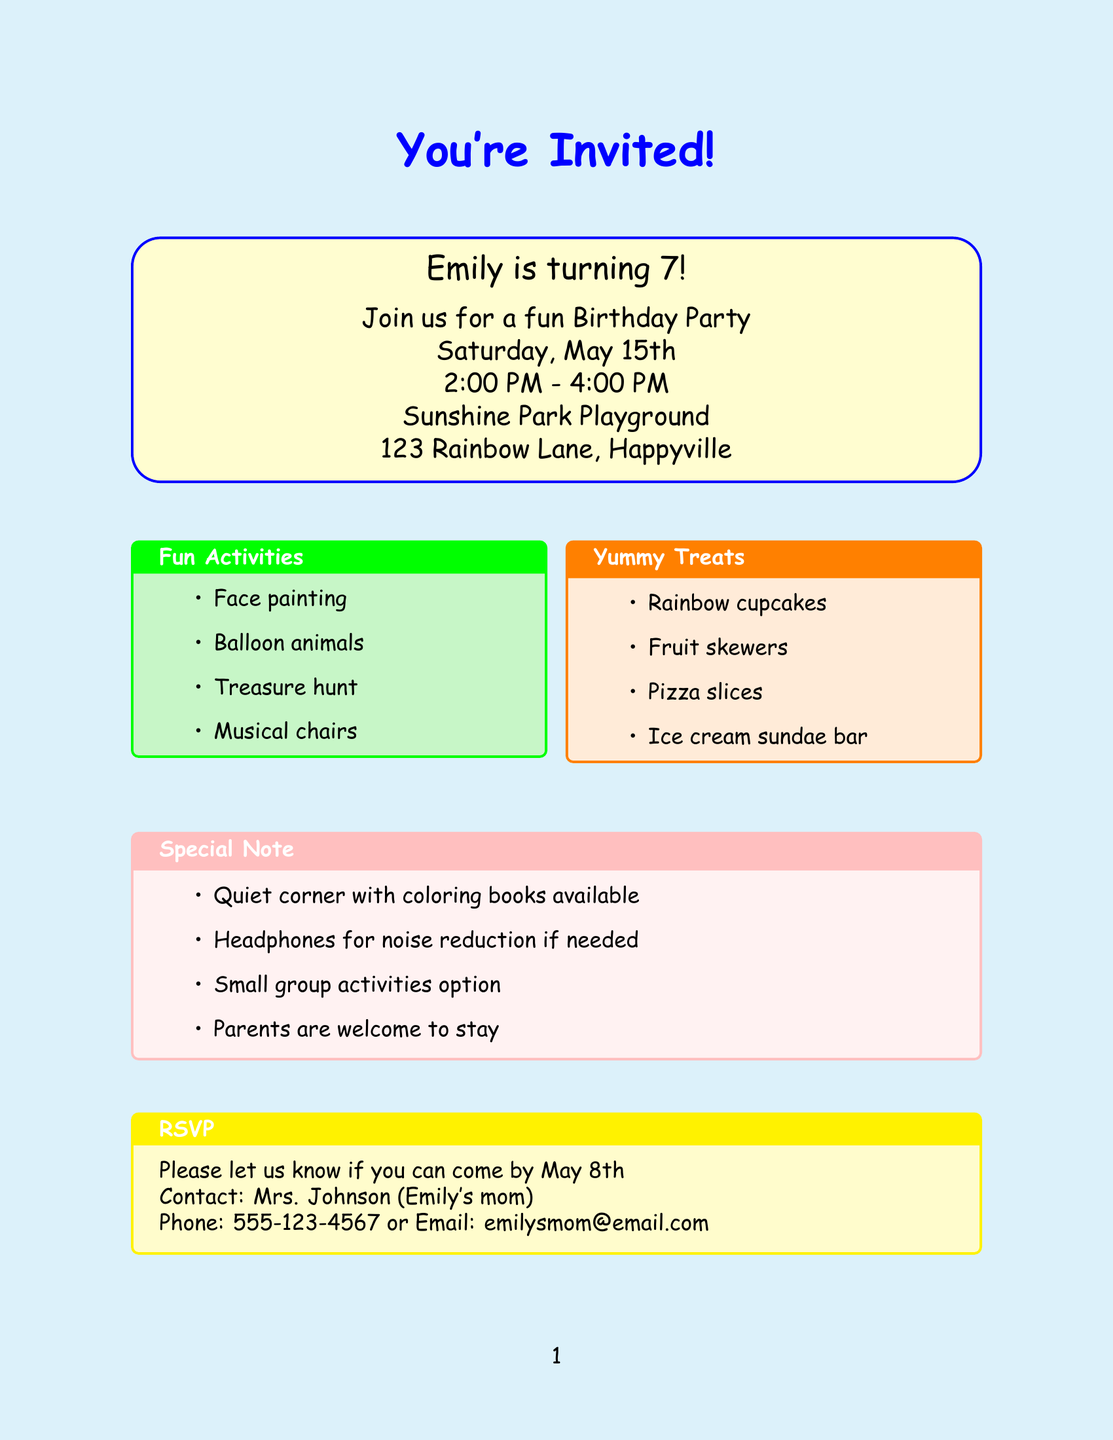What is the name of the host? The host of the birthday party, as mentioned in the document, is Emily.
Answer: Emily How old is Emily turning? The document states that Emily is turning 7 years old.
Answer: 7 When is the birthday party? According to the details in the document, the birthday party is scheduled for Saturday, May 15th.
Answer: Saturday, May 15th Where is the location of the party? The address provided in the document for the birthday party location is 123 Rainbow Lane, Happyville.
Answer: 123 Rainbow Lane, Happyville What type of food will be served? The document lists several food items, one of which is rainbow cupcakes.
Answer: Rainbow cupcakes What special accommodations are available? The document mentions a quiet corner with coloring books as one of the special accommodations.
Answer: Quiet corner with coloring books What time does the party start? The party starts at 2:00 PM, as indicated in the invitation details.
Answer: 2:00 PM What are the fun activities? One of the fun activities listed in the document is balloon animals.
Answer: Balloon animals When is the RSVP deadline? The document states that the RSVP deadline is May 8th.
Answer: May 8th Who can you contact for RSVP? The contact person for the RSVP mentioned in the document is Mrs. Johnson.
Answer: Mrs. Johnson 